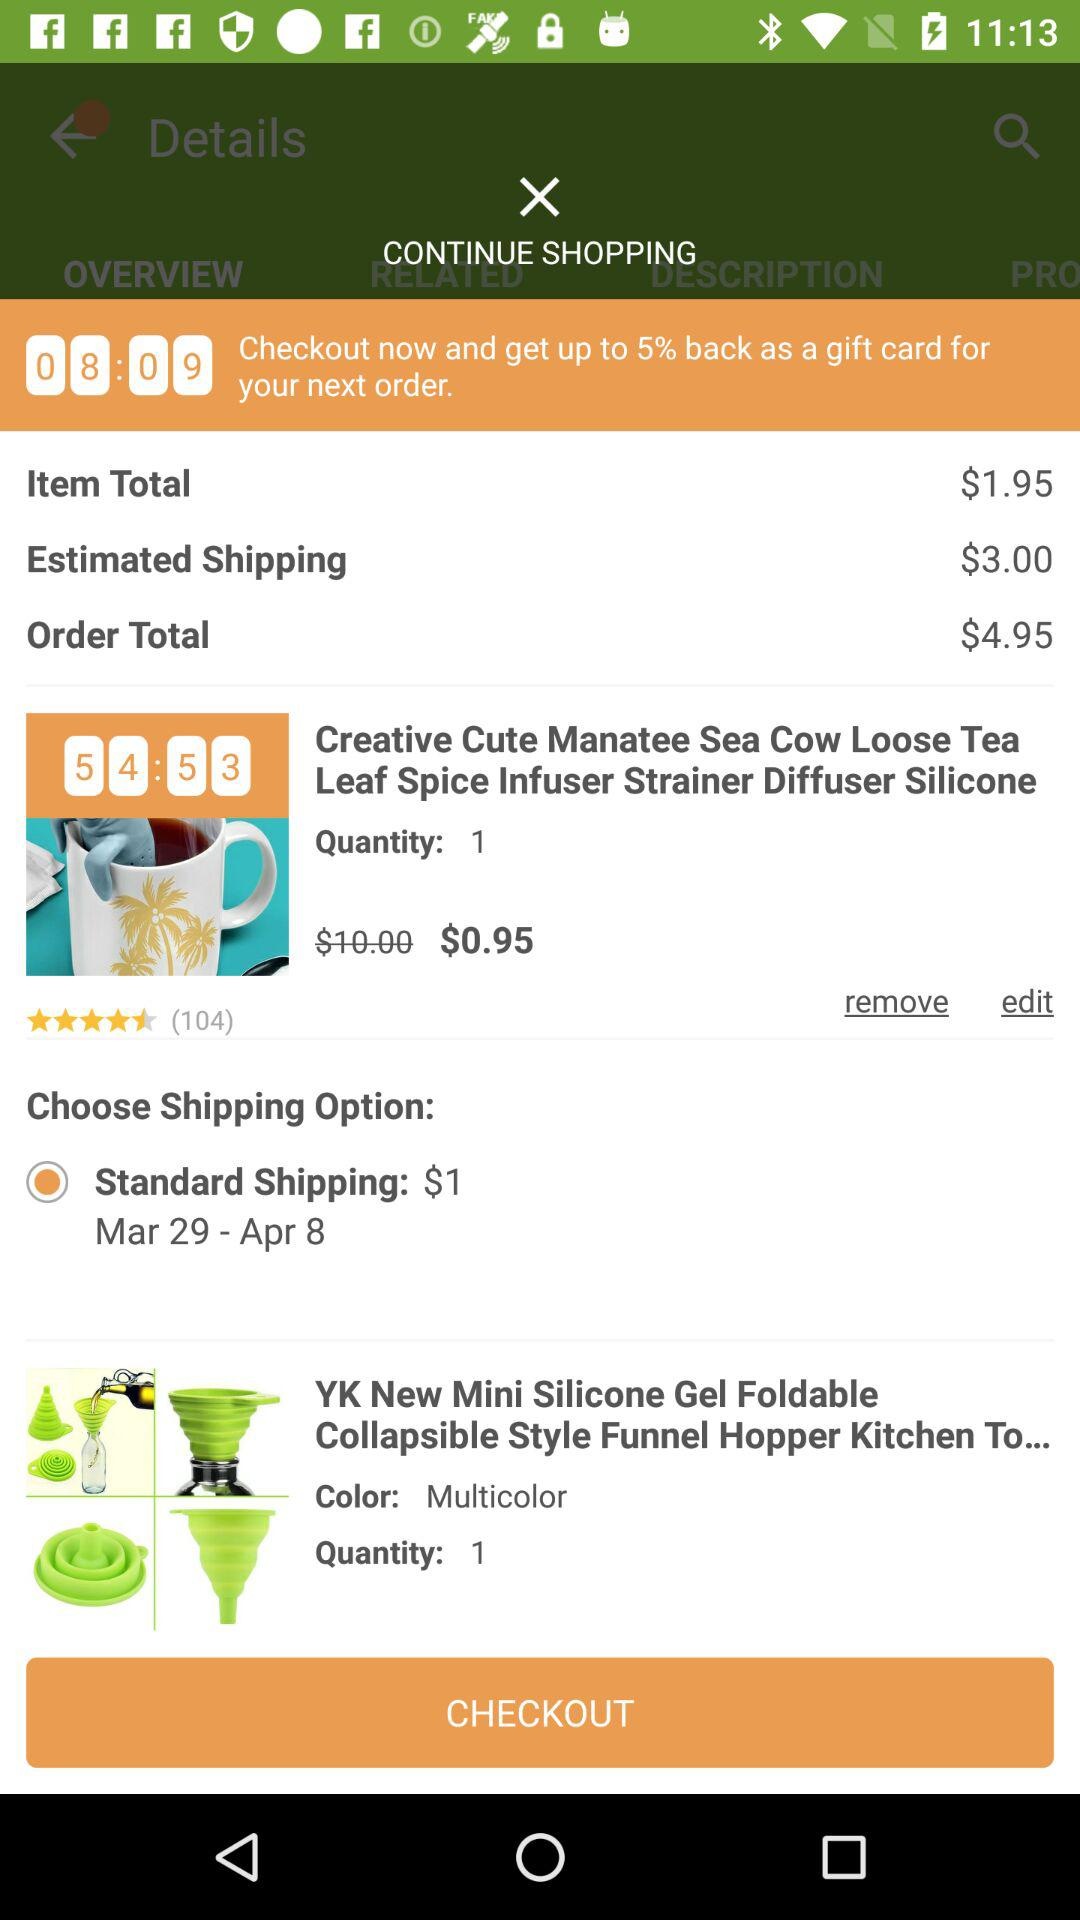How many items are in my cart?
Answer the question using a single word or phrase. 2 